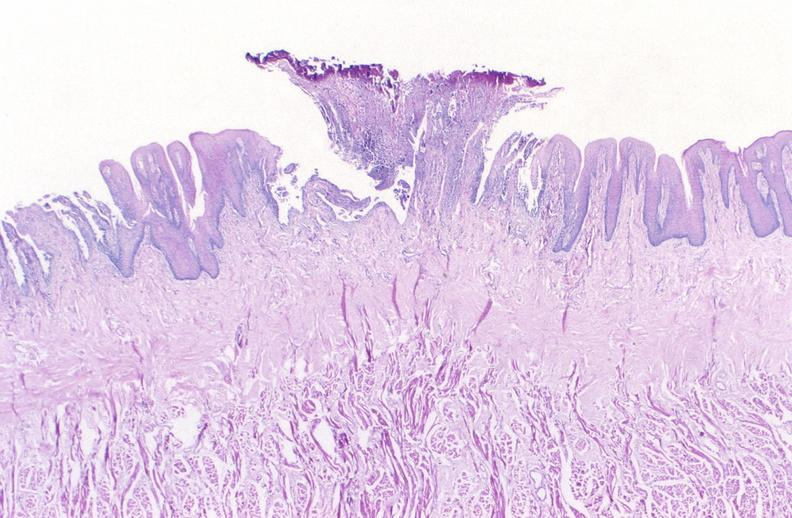where is this from?
Answer the question using a single word or phrase. Gastrointestinal system 